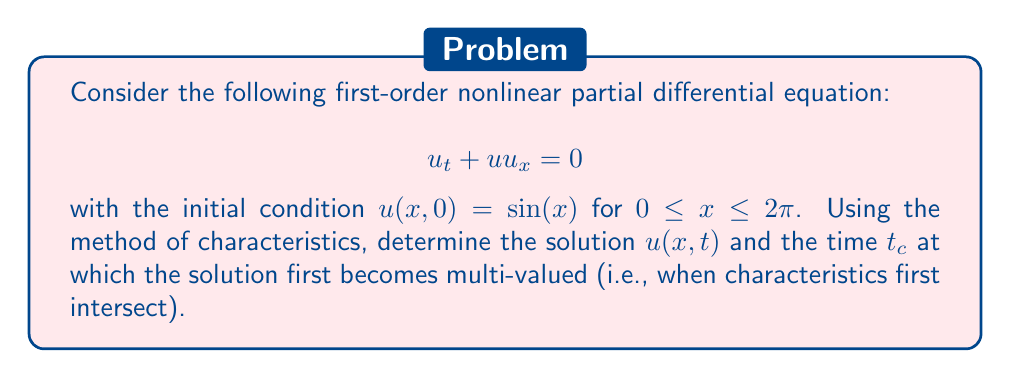Solve this math problem. Let's solve this problem step by step using the method of characteristics:

1) The characteristic equations for this PDE are:
   $$\frac{dx}{dt} = u$$
   $$\frac{du}{dt} = 0$$

2) From the second equation, we can conclude that $u$ is constant along characteristics. Let's denote this constant as $c$.

3) The first equation then becomes $\frac{dx}{dt} = c$, which integrates to:
   $$x = ct + x_0$$
   where $x_0$ is the initial x-coordinate of the characteristic.

4) From the initial condition, we have $u(x_0, 0) = \sin(x_0) = c$.

5) Therefore, the general solution is:
   $$u = \sin(x_0) = \sin(x - ut)$$

6) To find when the solution becomes multi-valued, we need to find when $\frac{\partial x}{\partial x_0} = 0$:
   $$\frac{\partial x}{\partial x_0} = 1 - t\cos(x_0) = 0$$

7) This occurs first when $t\cos(x_0) = 1$ and $\cos(x_0)$ is at its maximum value of 1.

8) Therefore, the critical time $t_c$ is:
   $$t_c = 1$$

9) The complete solution $u(x,t)$ is implicitly defined by:
   $$u = \sin(x - ut)$$
   for $0 \leq t < 1$, and becomes multi-valued for $t \geq 1$.
Answer: $u = \sin(x - ut)$ for $0 \leq t < 1$; $t_c = 1$ 